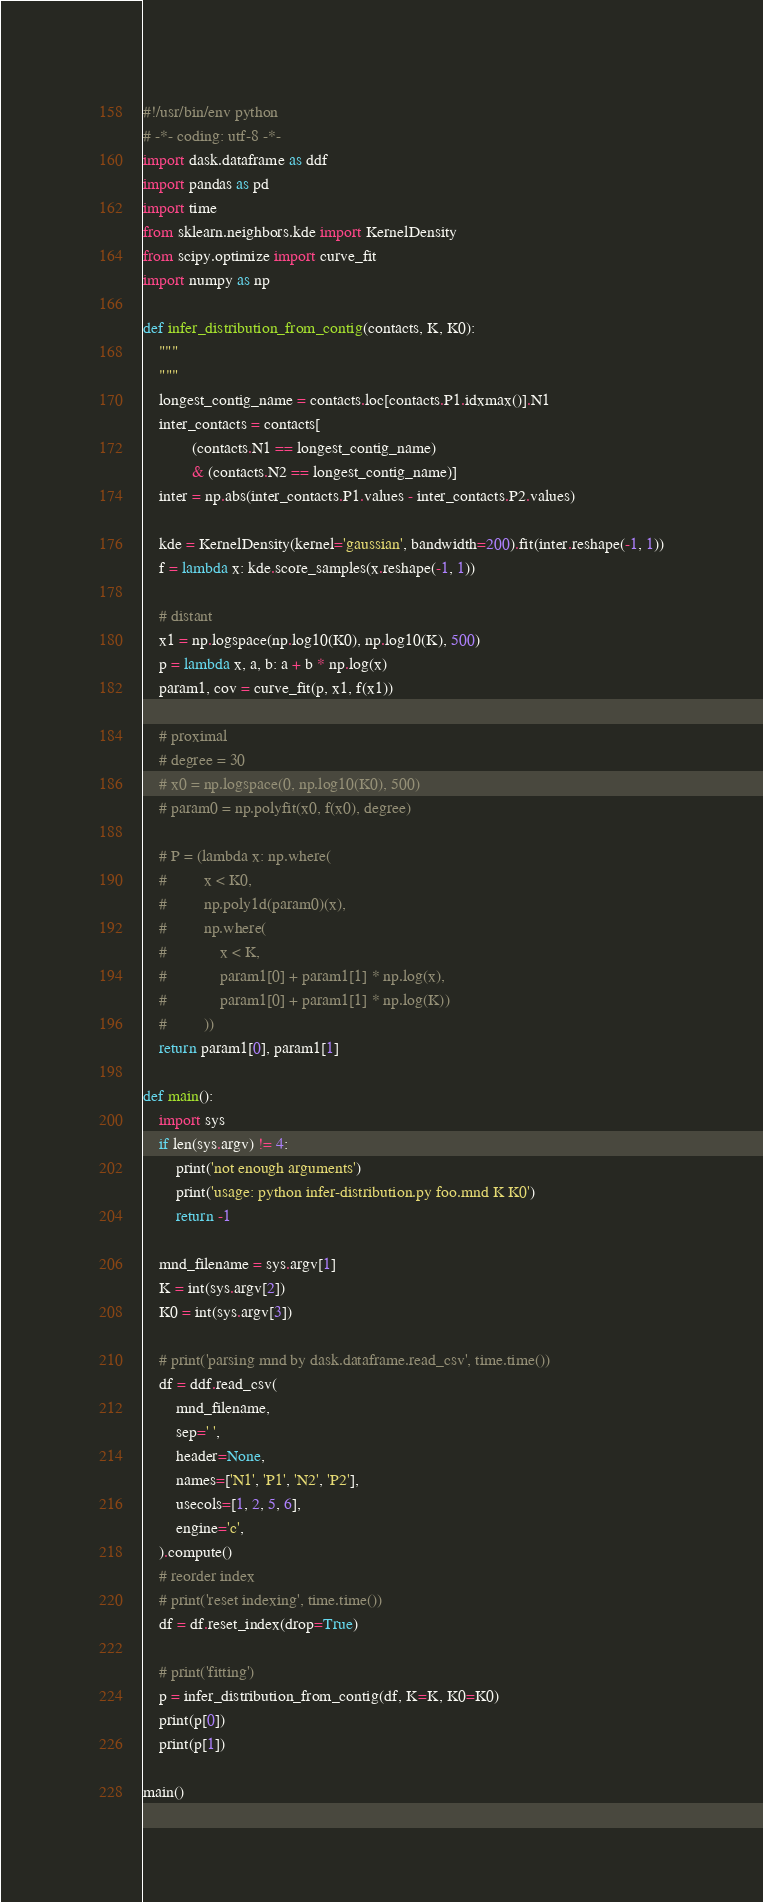<code> <loc_0><loc_0><loc_500><loc_500><_Python_>#!/usr/bin/env python
# -*- coding: utf-8 -*-
import dask.dataframe as ddf
import pandas as pd
import time
from sklearn.neighbors.kde import KernelDensity
from scipy.optimize import curve_fit
import numpy as np

def infer_distribution_from_contig(contacts, K, K0):
    """
    """
    longest_contig_name = contacts.loc[contacts.P1.idxmax()].N1
    inter_contacts = contacts[
            (contacts.N1 == longest_contig_name)
            & (contacts.N2 == longest_contig_name)]
    inter = np.abs(inter_contacts.P1.values - inter_contacts.P2.values)

    kde = KernelDensity(kernel='gaussian', bandwidth=200).fit(inter.reshape(-1, 1))
    f = lambda x: kde.score_samples(x.reshape(-1, 1))

    # distant
    x1 = np.logspace(np.log10(K0), np.log10(K), 500)
    p = lambda x, a, b: a + b * np.log(x)
    param1, cov = curve_fit(p, x1, f(x1))

    # proximal
    # degree = 30
    # x0 = np.logspace(0, np.log10(K0), 500)
    # param0 = np.polyfit(x0, f(x0), degree)

    # P = (lambda x: np.where(
    #         x < K0,
    #         np.poly1d(param0)(x),
    #         np.where(
    #             x < K,
    #             param1[0] + param1[1] * np.log(x),
    #             param1[0] + param1[1] * np.log(K))
    #         ))
    return param1[0], param1[1]

def main():
    import sys
    if len(sys.argv) != 4:
        print('not enough arguments')
        print('usage: python infer-distribution.py foo.mnd K K0')
        return -1

    mnd_filename = sys.argv[1]
    K = int(sys.argv[2])
    K0 = int(sys.argv[3])

    # print('parsing mnd by dask.dataframe.read_csv', time.time())
    df = ddf.read_csv(
        mnd_filename,
        sep=' ',
        header=None,
        names=['N1', 'P1', 'N2', 'P2'],
        usecols=[1, 2, 5, 6],
        engine='c',
    ).compute()
    # reorder index
    # print('reset indexing', time.time())
    df = df.reset_index(drop=True)

    # print('fitting')
    p = infer_distribution_from_contig(df, K=K, K0=K0)
    print(p[0])
    print(p[1])

main()
</code> 